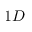Convert formula to latex. <formula><loc_0><loc_0><loc_500><loc_500>1 D</formula> 